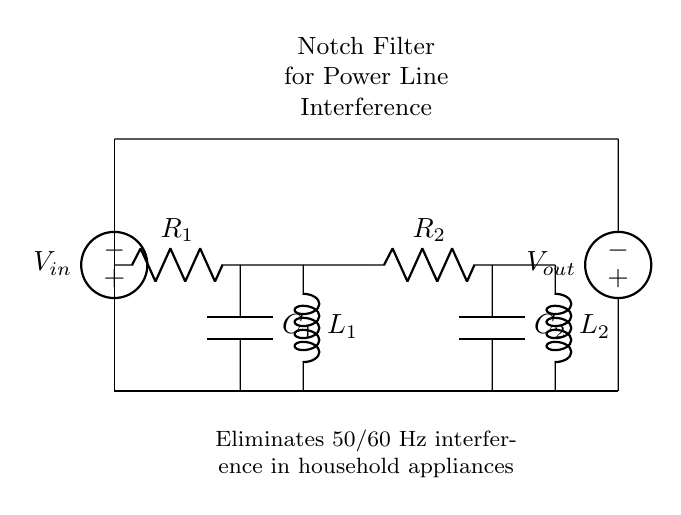What components are used in the notch filter? The circuit uses resistors, capacitors, and inductors as its primary components. Specifically, it includes two resistors labeled R1 and R2, two capacitors labeled C1 and C2, and two inductors labeled L1 and L2.
Answer: resistors, capacitors, inductors What is the purpose of this notch filter? The notch filter is designed to eliminate interference from power lines, specifically targeting frequencies common in electrical systems, such as 50 or 60 Hz. This means it helps reduce unwanted noise from household appliances that operate at these frequencies.
Answer: eliminate power line interference How many inductors are present in the circuit? The circuit diagram shows two inductors labeled L1 and L2. Each inductor contributes to the filtering action of the circuit by providing a specific impedance to the signals in the target frequency range.
Answer: two What is the input voltage source labeled as? The input voltage source fed into the circuit is labeled as V_in, which typically represents the voltage supplying energy to the circuit. This voltage drives the signals that the notch filter will process.
Answer: V_in What frequency does the notch filter eliminate? The notch filter is specifically designed to eliminate interference at frequencies of 50/60 Hz, which correspond to the frequency of the electrical supply in most households. This frequency targeting is crucial for effectively reducing power line noise.
Answer: 50/60 Hz What type of circuit is this? This circuit is classified as a notch filter, which is a specific kind of filter that is used to eliminate a narrow band of frequencies, in this case to prevent interference from power line frequencies in household applications.
Answer: notch filter How are the components arranged in relation to each other? The components are arranged in a specific sequence: two resistors, two capacitors, and two inductors are connected in a way that allows the filter to properly attenuate the target frequency while passing other frequencies. The arrangement follows a specific order that defines the filter's characteristics.
Answer: sequenced arrangement 